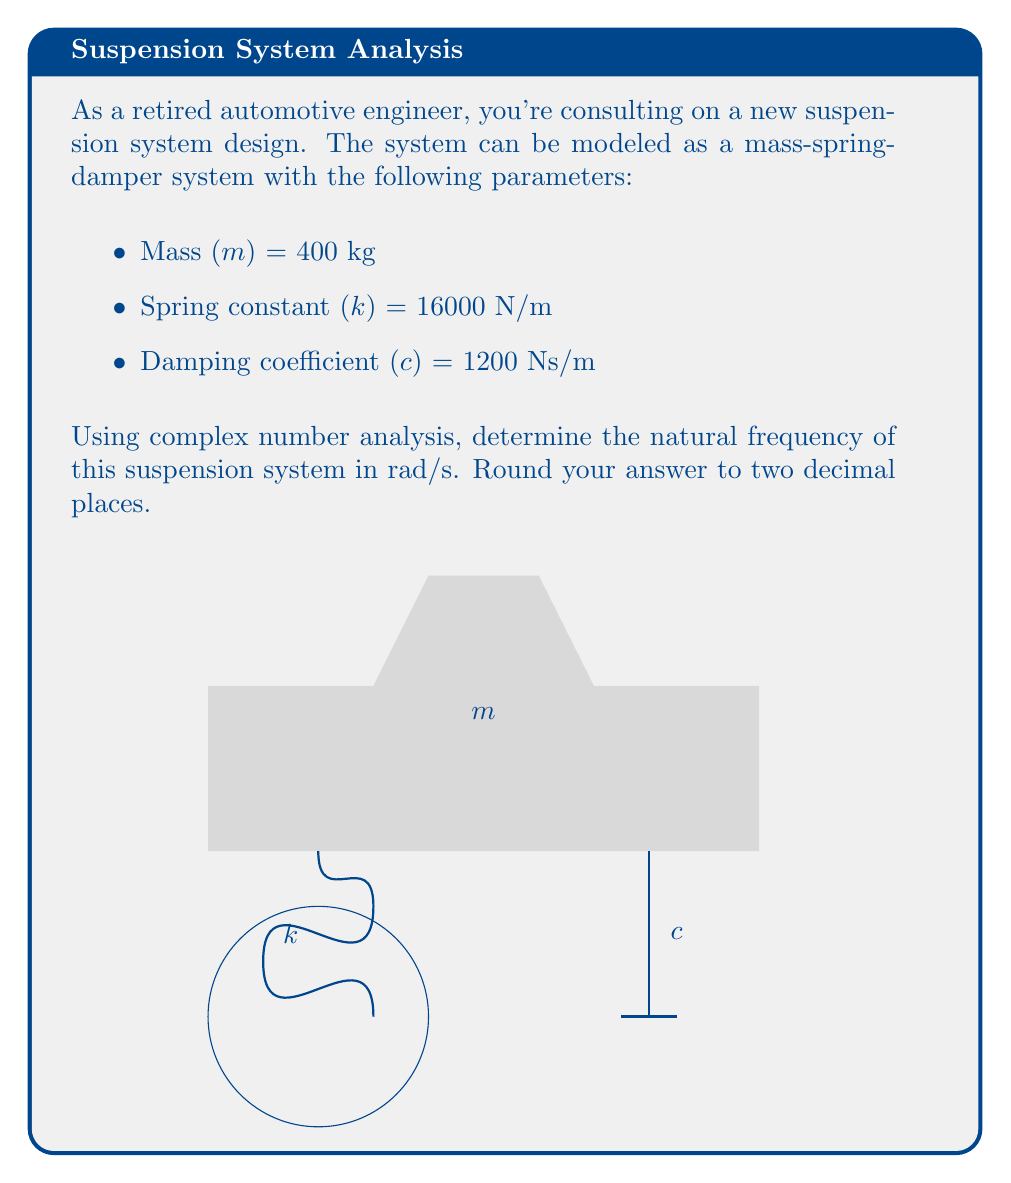Can you solve this math problem? To determine the natural frequency of the suspension system using complex numbers, we'll follow these steps:

1) The equation of motion for a mass-spring-damper system is:

   $$m\ddot{x} + c\dot{x} + kx = 0$$

2) We assume a solution of the form $x = Ae^{st}$, where $s$ is a complex number.

3) Substituting this into the equation of motion:

   $$ms^2Ae^{st} + csAe^{st} + kAe^{st} = 0$$

4) Dividing by $Ae^{st}$:

   $$ms^2 + cs + k = 0$$

5) This is the characteristic equation. The roots of this equation give us the complex natural frequencies.

6) The general form of the roots is:

   $$s = -\zeta\omega_n \pm i\omega_n\sqrt{1-\zeta^2}$$

   where $\omega_n$ is the undamped natural frequency and $\zeta$ is the damping ratio.

7) The undamped natural frequency $\omega_n$ is given by:

   $$\omega_n = \sqrt{\frac{k}{m}}$$

8) Substituting the given values:

   $$\omega_n = \sqrt{\frac{16000}{400}} = \sqrt{40} = 6.32 \text{ rad/s}$$

9) We round to two decimal places as requested.
Answer: $6.32 \text{ rad/s}$ 